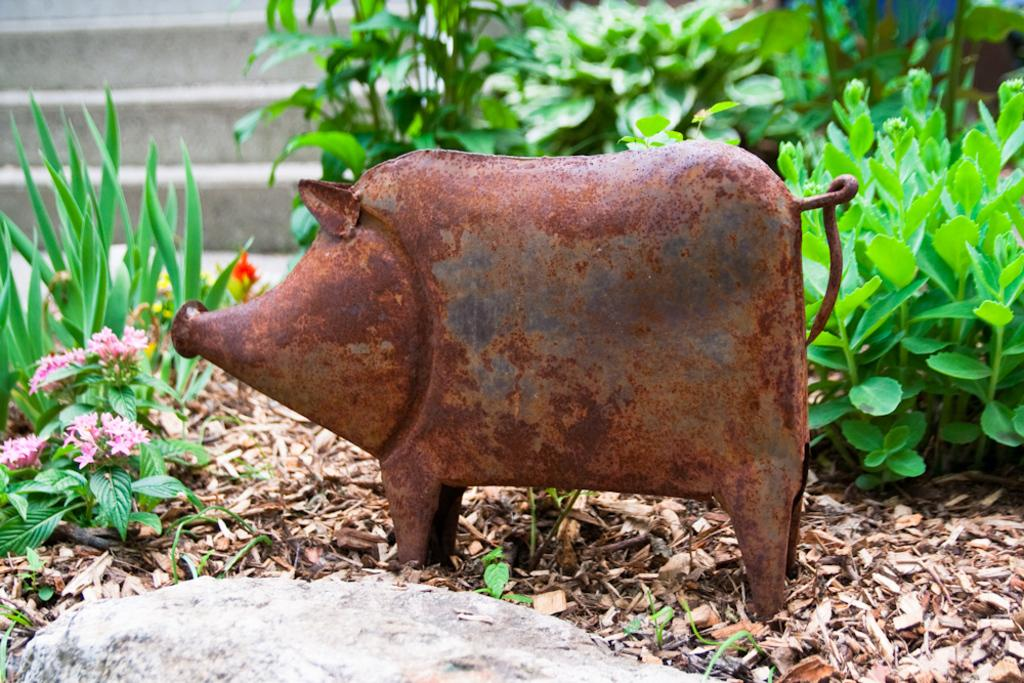What type of animal is in the image? There is a pig in the image. What material is the pig made of? The pig is made of iron. Where is the pig located in the image? The pig is kept on the ground. What type of clover is the pig eating in the image? There is no clover present in the image, and the pig is made of iron, so it cannot eat clover. 